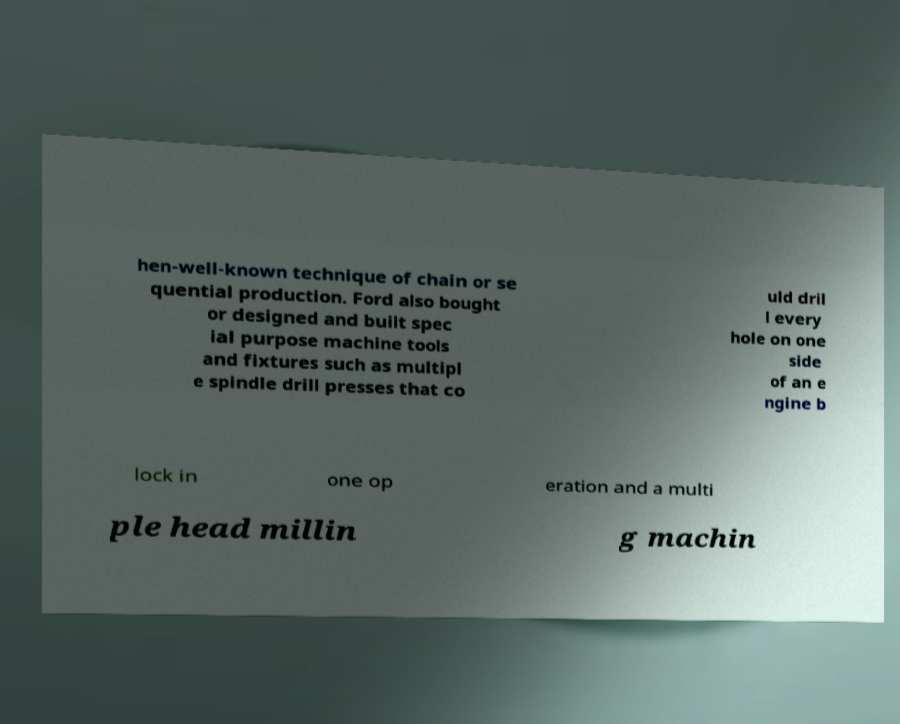There's text embedded in this image that I need extracted. Can you transcribe it verbatim? hen-well-known technique of chain or se quential production. Ford also bought or designed and built spec ial purpose machine tools and fixtures such as multipl e spindle drill presses that co uld dril l every hole on one side of an e ngine b lock in one op eration and a multi ple head millin g machin 